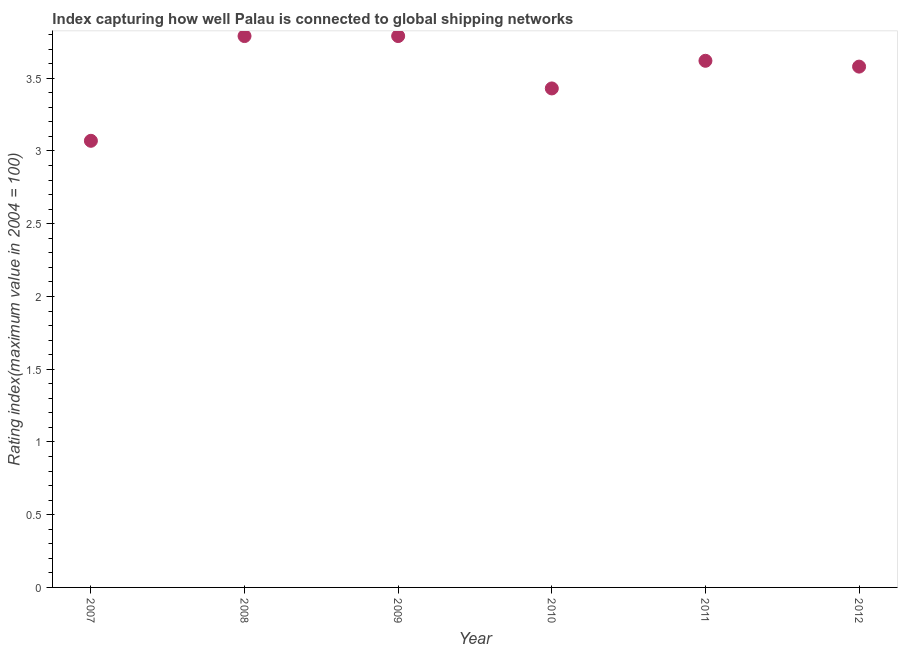What is the liner shipping connectivity index in 2010?
Keep it short and to the point. 3.43. Across all years, what is the maximum liner shipping connectivity index?
Your response must be concise. 3.79. Across all years, what is the minimum liner shipping connectivity index?
Give a very brief answer. 3.07. In which year was the liner shipping connectivity index minimum?
Give a very brief answer. 2007. What is the sum of the liner shipping connectivity index?
Provide a short and direct response. 21.28. What is the difference between the liner shipping connectivity index in 2007 and 2009?
Keep it short and to the point. -0.72. What is the average liner shipping connectivity index per year?
Your answer should be compact. 3.55. In how many years, is the liner shipping connectivity index greater than 1.7 ?
Offer a terse response. 6. Do a majority of the years between 2011 and 2007 (inclusive) have liner shipping connectivity index greater than 3 ?
Your answer should be very brief. Yes. What is the ratio of the liner shipping connectivity index in 2008 to that in 2010?
Ensure brevity in your answer.  1.1. Is the difference between the liner shipping connectivity index in 2010 and 2011 greater than the difference between any two years?
Your response must be concise. No. Is the sum of the liner shipping connectivity index in 2009 and 2010 greater than the maximum liner shipping connectivity index across all years?
Offer a terse response. Yes. What is the difference between the highest and the lowest liner shipping connectivity index?
Offer a very short reply. 0.72. In how many years, is the liner shipping connectivity index greater than the average liner shipping connectivity index taken over all years?
Offer a terse response. 4. Does the graph contain any zero values?
Ensure brevity in your answer.  No. What is the title of the graph?
Provide a short and direct response. Index capturing how well Palau is connected to global shipping networks. What is the label or title of the Y-axis?
Make the answer very short. Rating index(maximum value in 2004 = 100). What is the Rating index(maximum value in 2004 = 100) in 2007?
Offer a very short reply. 3.07. What is the Rating index(maximum value in 2004 = 100) in 2008?
Your answer should be very brief. 3.79. What is the Rating index(maximum value in 2004 = 100) in 2009?
Your answer should be compact. 3.79. What is the Rating index(maximum value in 2004 = 100) in 2010?
Give a very brief answer. 3.43. What is the Rating index(maximum value in 2004 = 100) in 2011?
Provide a short and direct response. 3.62. What is the Rating index(maximum value in 2004 = 100) in 2012?
Give a very brief answer. 3.58. What is the difference between the Rating index(maximum value in 2004 = 100) in 2007 and 2008?
Make the answer very short. -0.72. What is the difference between the Rating index(maximum value in 2004 = 100) in 2007 and 2009?
Provide a short and direct response. -0.72. What is the difference between the Rating index(maximum value in 2004 = 100) in 2007 and 2010?
Your response must be concise. -0.36. What is the difference between the Rating index(maximum value in 2004 = 100) in 2007 and 2011?
Make the answer very short. -0.55. What is the difference between the Rating index(maximum value in 2004 = 100) in 2007 and 2012?
Keep it short and to the point. -0.51. What is the difference between the Rating index(maximum value in 2004 = 100) in 2008 and 2010?
Offer a terse response. 0.36. What is the difference between the Rating index(maximum value in 2004 = 100) in 2008 and 2011?
Give a very brief answer. 0.17. What is the difference between the Rating index(maximum value in 2004 = 100) in 2008 and 2012?
Your answer should be compact. 0.21. What is the difference between the Rating index(maximum value in 2004 = 100) in 2009 and 2010?
Ensure brevity in your answer.  0.36. What is the difference between the Rating index(maximum value in 2004 = 100) in 2009 and 2011?
Keep it short and to the point. 0.17. What is the difference between the Rating index(maximum value in 2004 = 100) in 2009 and 2012?
Your answer should be compact. 0.21. What is the difference between the Rating index(maximum value in 2004 = 100) in 2010 and 2011?
Give a very brief answer. -0.19. What is the ratio of the Rating index(maximum value in 2004 = 100) in 2007 to that in 2008?
Your answer should be compact. 0.81. What is the ratio of the Rating index(maximum value in 2004 = 100) in 2007 to that in 2009?
Offer a very short reply. 0.81. What is the ratio of the Rating index(maximum value in 2004 = 100) in 2007 to that in 2010?
Provide a short and direct response. 0.9. What is the ratio of the Rating index(maximum value in 2004 = 100) in 2007 to that in 2011?
Provide a succinct answer. 0.85. What is the ratio of the Rating index(maximum value in 2004 = 100) in 2007 to that in 2012?
Your response must be concise. 0.86. What is the ratio of the Rating index(maximum value in 2004 = 100) in 2008 to that in 2010?
Make the answer very short. 1.1. What is the ratio of the Rating index(maximum value in 2004 = 100) in 2008 to that in 2011?
Make the answer very short. 1.05. What is the ratio of the Rating index(maximum value in 2004 = 100) in 2008 to that in 2012?
Offer a terse response. 1.06. What is the ratio of the Rating index(maximum value in 2004 = 100) in 2009 to that in 2010?
Offer a very short reply. 1.1. What is the ratio of the Rating index(maximum value in 2004 = 100) in 2009 to that in 2011?
Make the answer very short. 1.05. What is the ratio of the Rating index(maximum value in 2004 = 100) in 2009 to that in 2012?
Your answer should be compact. 1.06. What is the ratio of the Rating index(maximum value in 2004 = 100) in 2010 to that in 2011?
Keep it short and to the point. 0.95. What is the ratio of the Rating index(maximum value in 2004 = 100) in 2010 to that in 2012?
Provide a short and direct response. 0.96. What is the ratio of the Rating index(maximum value in 2004 = 100) in 2011 to that in 2012?
Offer a terse response. 1.01. 